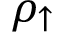Convert formula to latex. <formula><loc_0><loc_0><loc_500><loc_500>\rho _ { \uparrow }</formula> 